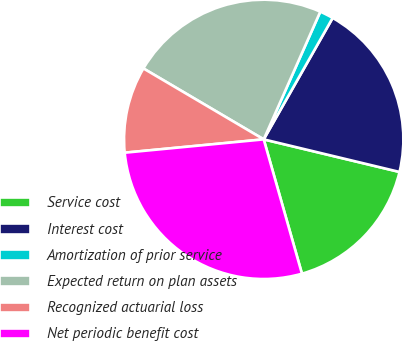<chart> <loc_0><loc_0><loc_500><loc_500><pie_chart><fcel>Service cost<fcel>Interest cost<fcel>Amortization of prior service<fcel>Expected return on plan assets<fcel>Recognized actuarial loss<fcel>Net periodic benefit cost<nl><fcel>16.84%<fcel>20.53%<fcel>1.58%<fcel>23.16%<fcel>10.0%<fcel>27.89%<nl></chart> 